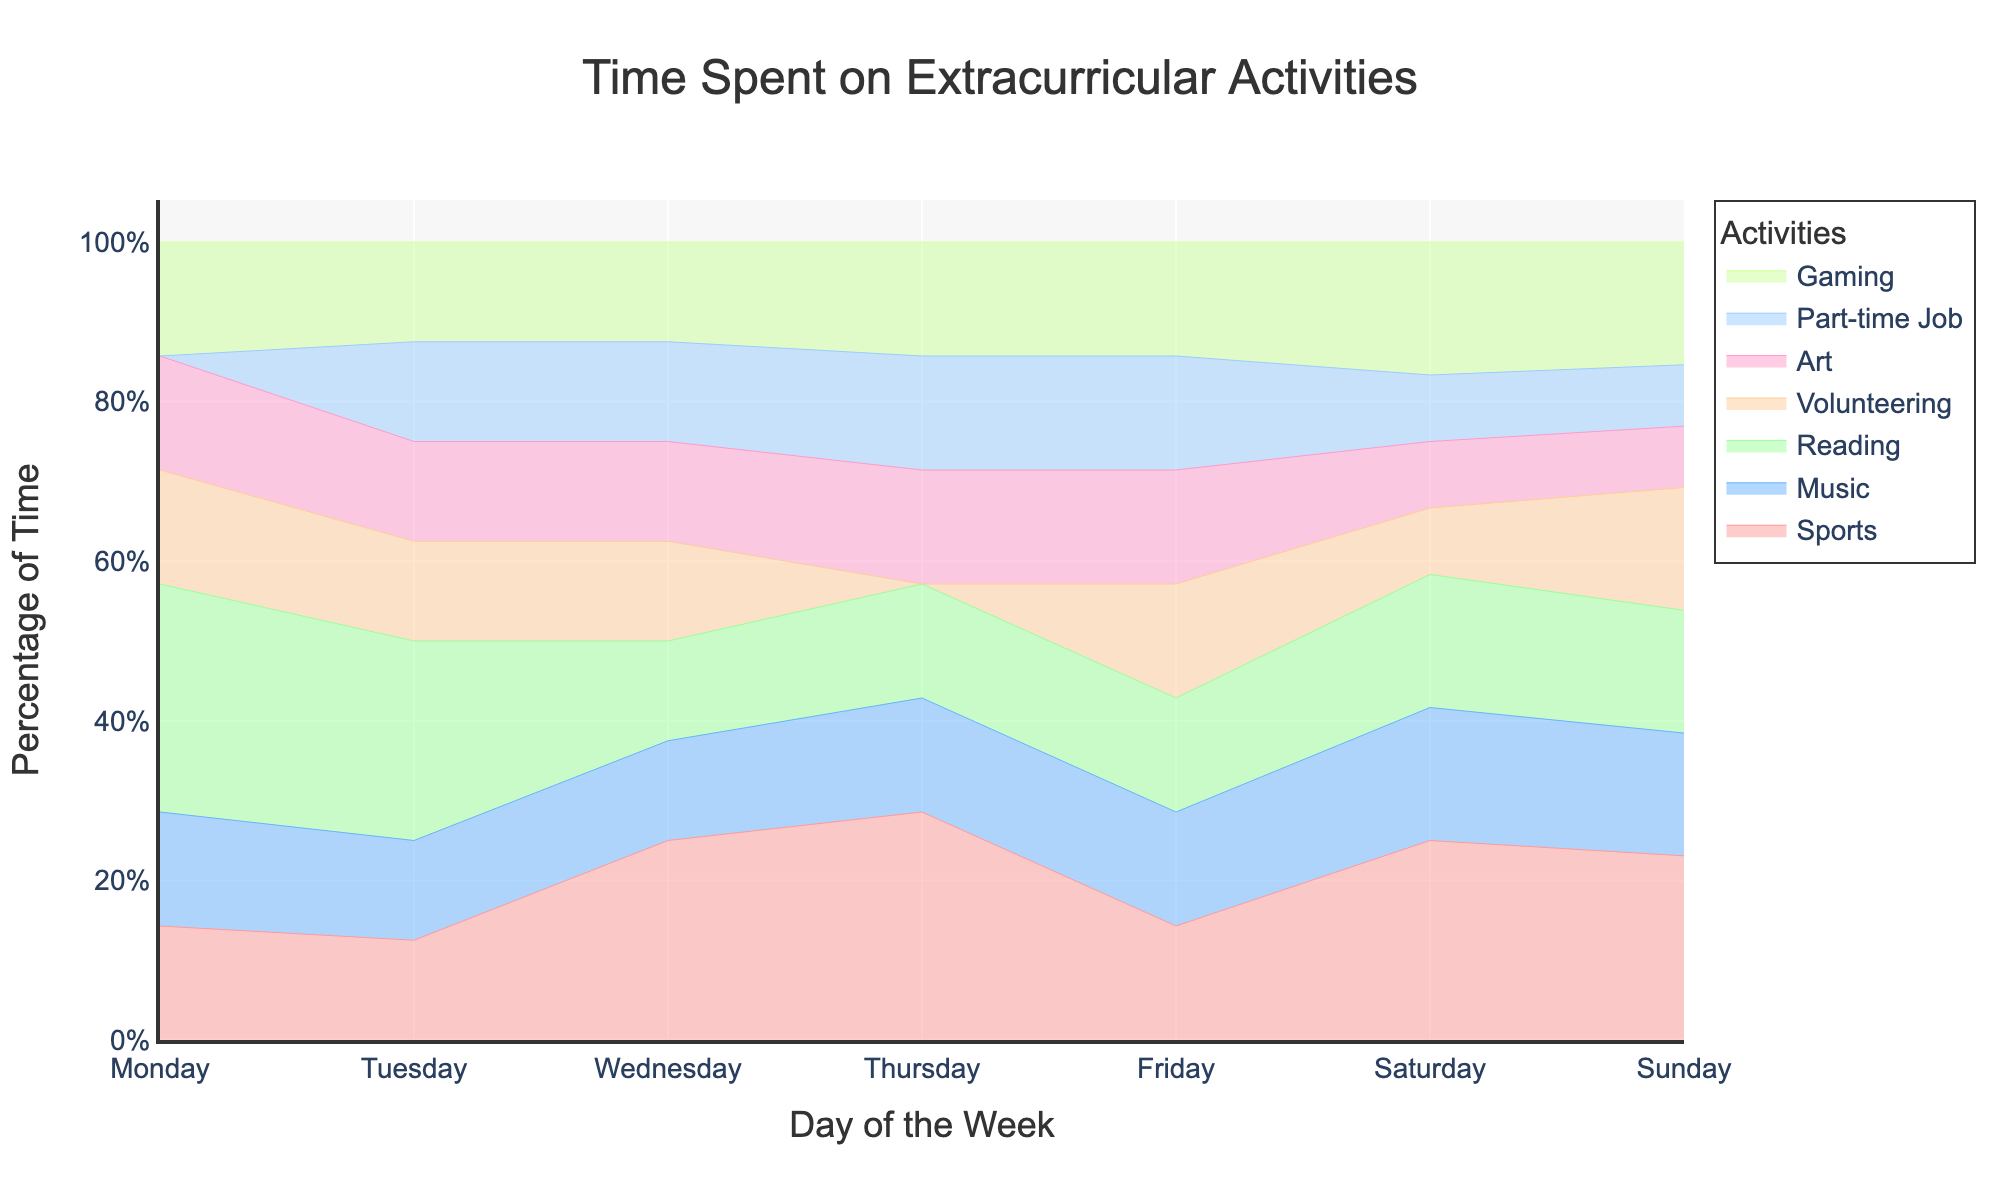What is the title of the chart? The title of the chart is usually displayed at the top. In this case, it reads "Time Spent on Extracurricular Activities".
Answer: Time Spent on Extracurricular Activities Which activity takes up the smallest percentage of time throughout the entire week? To find the activity with the smallest percentage of time, observe all the layers for each activity and find the one that consistently has the smallest height. In this case, "Art" always occupies a minimal percentage.
Answer: Art On which day is the percentage of time spent on gaming the highest? Look at the layer corresponding to gaming and observe which day shows the highest percentage. Here, gaming is highest on Saturday and Sunday.
Answer: Saturday and Sunday Which two activities combined take up the largest percentage of time on Sunday? Identify the two activities with the largest areas on Sunday by looking at their percentage shares. "Sports" and "Gaming" together take up the most space.
Answer: Sports and Gaming How does the percentage of time spent on music change from Monday to Sunday? Observe the height of the layer for music from Monday to Sunday. The percentage remains consistent on weekdays and increases slightly on weekends.
Answer: Increases slightly on weekends What is the total percentage of time spent on reading and volunteering on Thursday? Add the percentages of reading and volunteering on Thursday. From the chart, it looks like reading is around 11% and volunteering is 0%. So, 11% + 0% = 11%.
Answer: 11% How does the time spent on part-time jobs change throughout the week? Observe the layer for part-time jobs from Monday to Sunday. It's absent on Monday, starts low on Tuesday, and maintains almost the same percentage for the rest of the week.
Answer: Increases slightly from Tuesday onwards Which activity shows the most variation in percentage throughout the week? Compare the layers for each activity to see which one changes the most in height across the days. "Sports" and "Gaming" show significant variation.
Answer: Sports and Gaming Which day has the most evenly distributed time across all activities? Look for a day where the layers appear to be of similar height. Tuesday shows the most evenly distributed time across activities.
Answer: Tuesday 